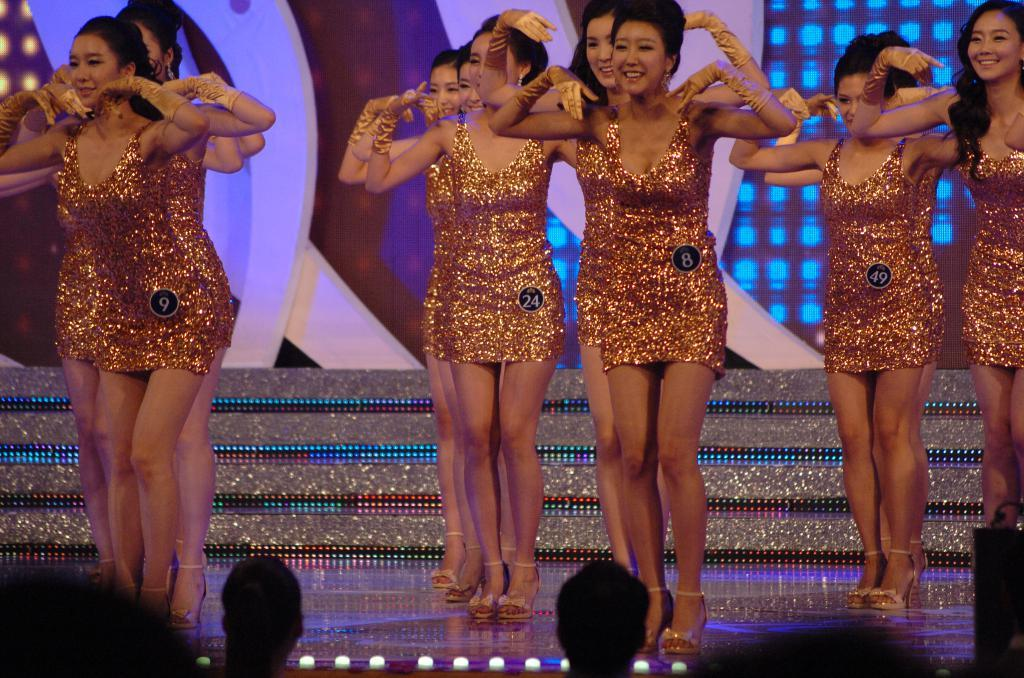What can be seen in the image? There are people standing in the image. What are the people wearing? The people are wearing gold color dresses. Where are the people standing? The people are on a stage. What is the background of the image like? There is a colorful background in the image. Are there any other people visible in the image? Yes, there are two people in front of the stage. What arithmetic problem is being solved by the bear in the stocking in the image? There is no bear or stocking present in the image, and therefore no arithmetic problem can be observed. 